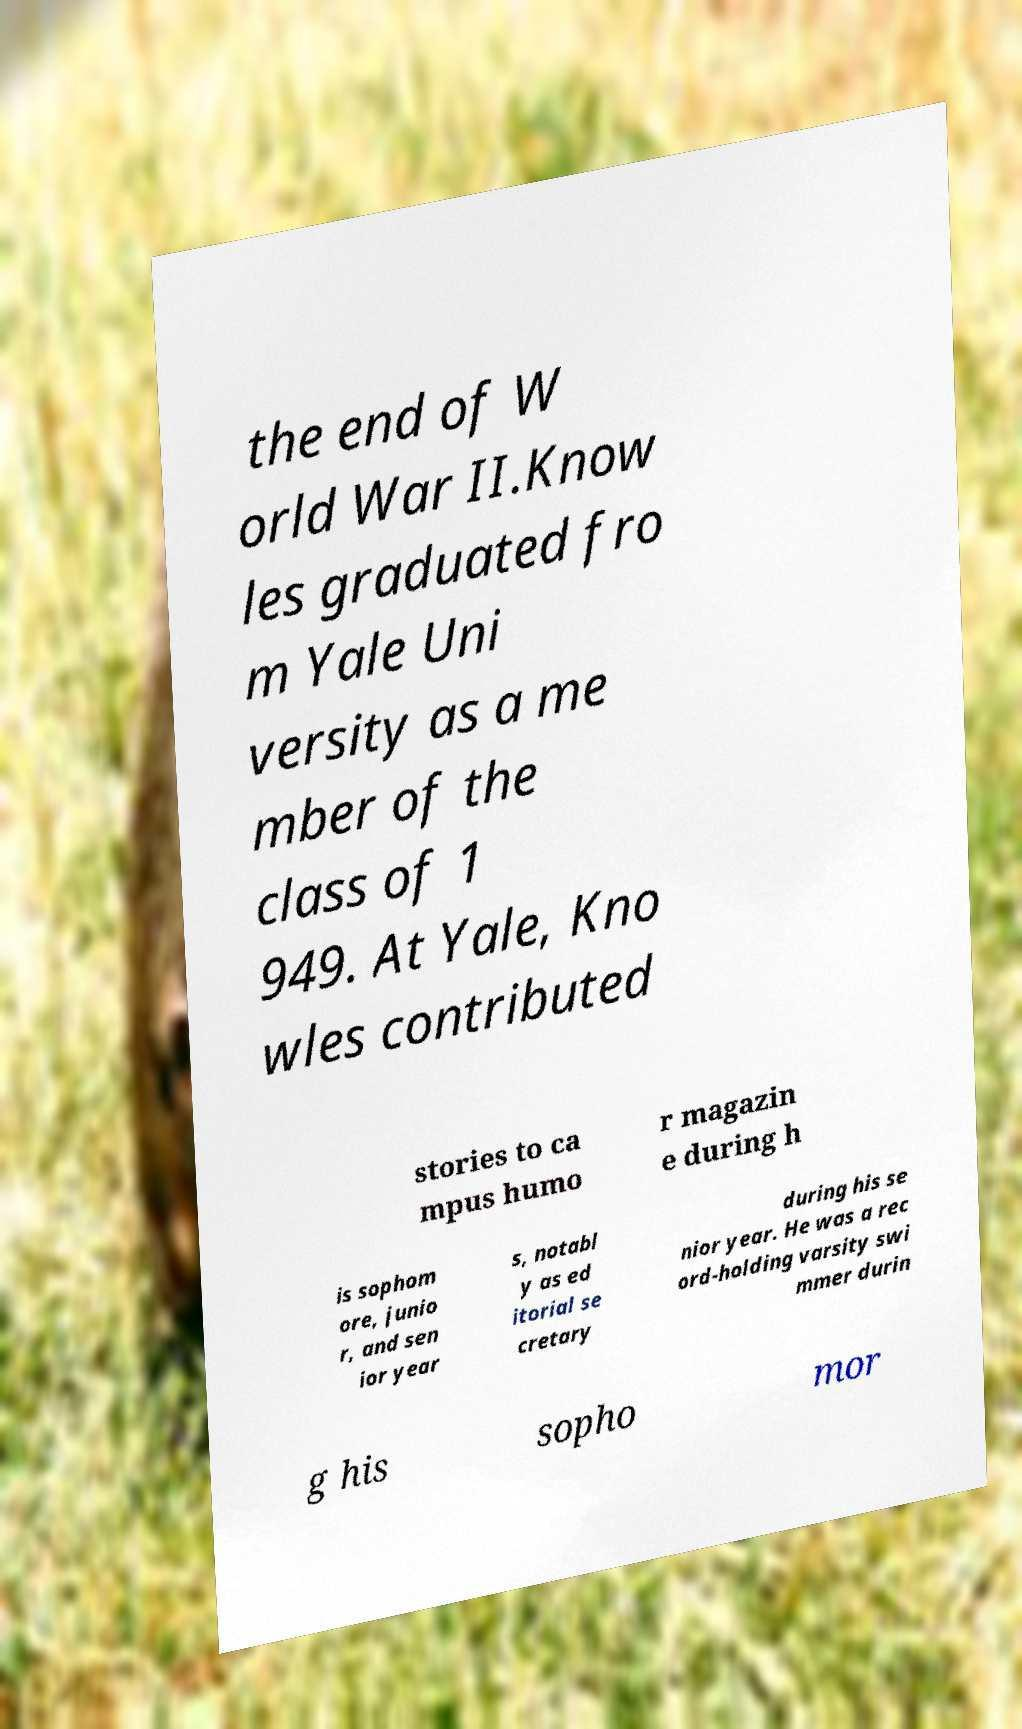What messages or text are displayed in this image? I need them in a readable, typed format. the end of W orld War II.Know les graduated fro m Yale Uni versity as a me mber of the class of 1 949. At Yale, Kno wles contributed stories to ca mpus humo r magazin e during h is sophom ore, junio r, and sen ior year s, notabl y as ed itorial se cretary during his se nior year. He was a rec ord-holding varsity swi mmer durin g his sopho mor 